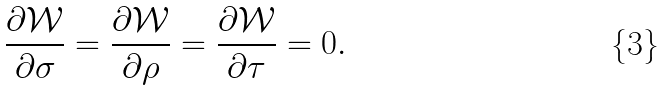<formula> <loc_0><loc_0><loc_500><loc_500>\frac { \partial \mathcal { W } } { \partial \sigma } = \frac { \partial \mathcal { W } } { \partial \rho } = \frac { \partial \mathcal { W } } { \partial \tau } = 0 .</formula> 